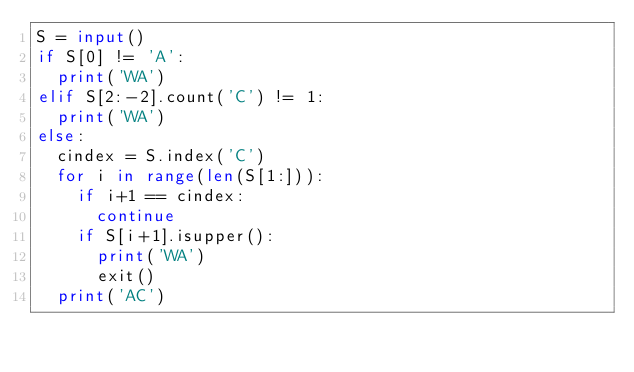Convert code to text. <code><loc_0><loc_0><loc_500><loc_500><_Python_>S = input()
if S[0] != 'A':
  print('WA')
elif S[2:-2].count('C') != 1:
  print('WA')
else:
  cindex = S.index('C')
  for i in range(len(S[1:])):
    if i+1 == cindex:
      continue
    if S[i+1].isupper():
      print('WA')
      exit()
  print('AC')</code> 